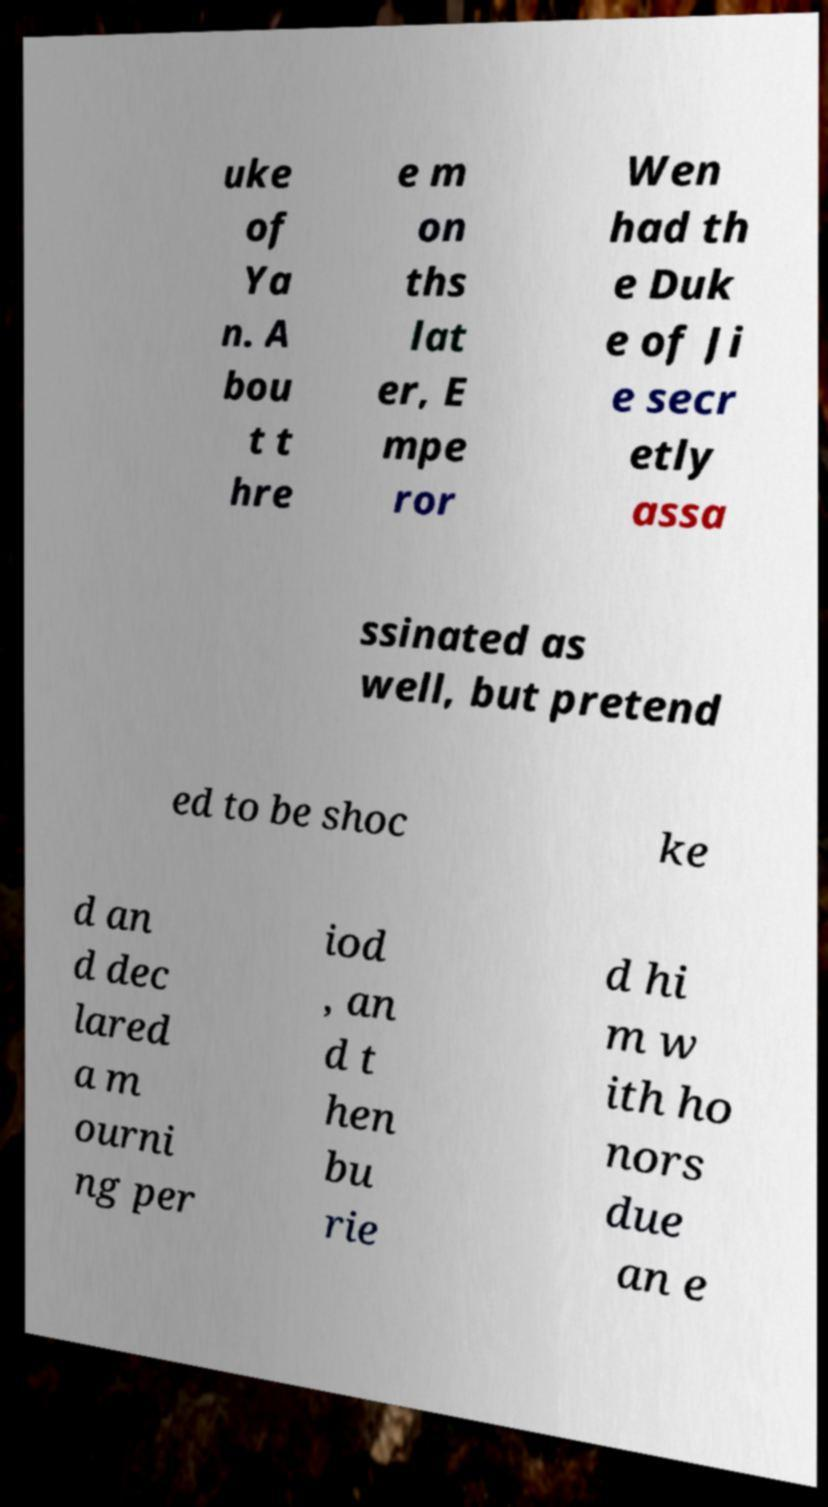I need the written content from this picture converted into text. Can you do that? uke of Ya n. A bou t t hre e m on ths lat er, E mpe ror Wen had th e Duk e of Ji e secr etly assa ssinated as well, but pretend ed to be shoc ke d an d dec lared a m ourni ng per iod , an d t hen bu rie d hi m w ith ho nors due an e 